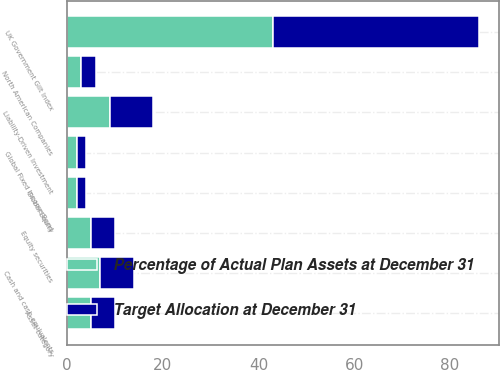Convert chart. <chart><loc_0><loc_0><loc_500><loc_500><stacked_bar_chart><ecel><fcel>Asset category<fcel>Cash and cash equivalents<fcel>North American Companies<fcel>Global Equity<fcel>Equity securities<fcel>UK Government Gilt Index<fcel>Global Fixed Income Bond<fcel>Liability-Driven Investment<nl><fcel>Target Allocation at December 31<fcel>5<fcel>7<fcel>3<fcel>2<fcel>5<fcel>43<fcel>2<fcel>9<nl><fcel>Percentage of Actual Plan Assets at December 31<fcel>5<fcel>7<fcel>3<fcel>2<fcel>5<fcel>43<fcel>2<fcel>9<nl></chart> 